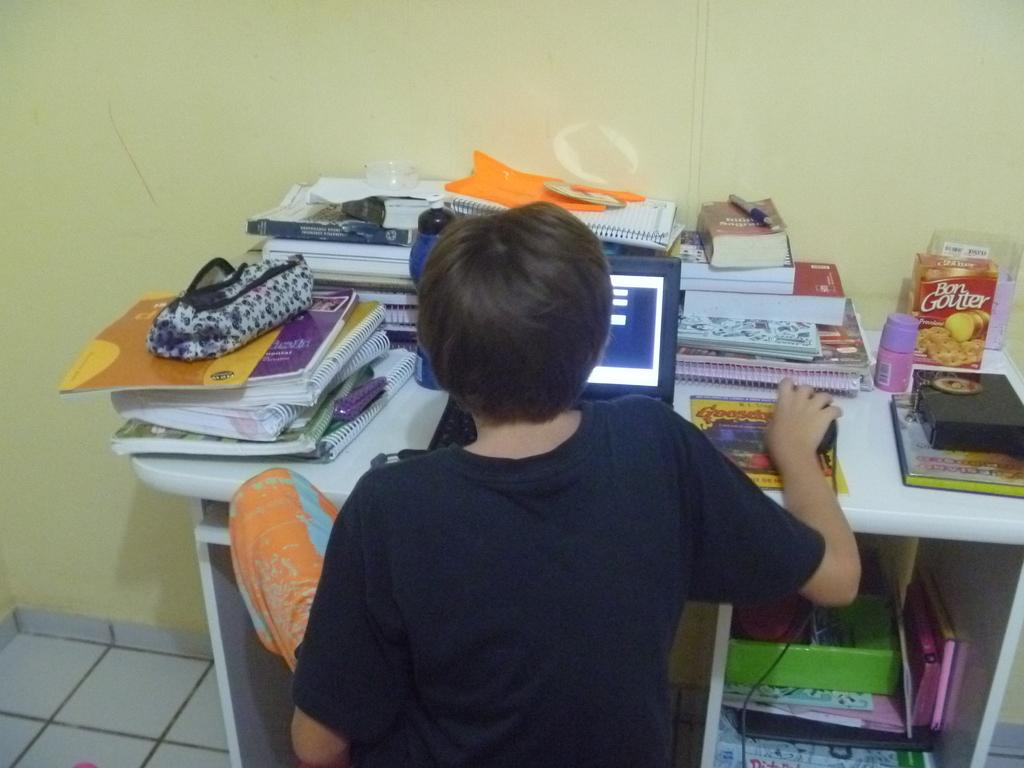What is the main subject of the image? The main subject of the image is a kid. What is the kid doing in the image? The kid is working on a laptop. What else can be seen on the table in the image? There are books and other objects on the table. Can you see a garden and a rake in the image? No, there is no garden or rake present in the image. Is there a locket visible on the kid's neck in the image? There is no mention of a locket in the provided facts, so we cannot determine if one is visible in the image. 